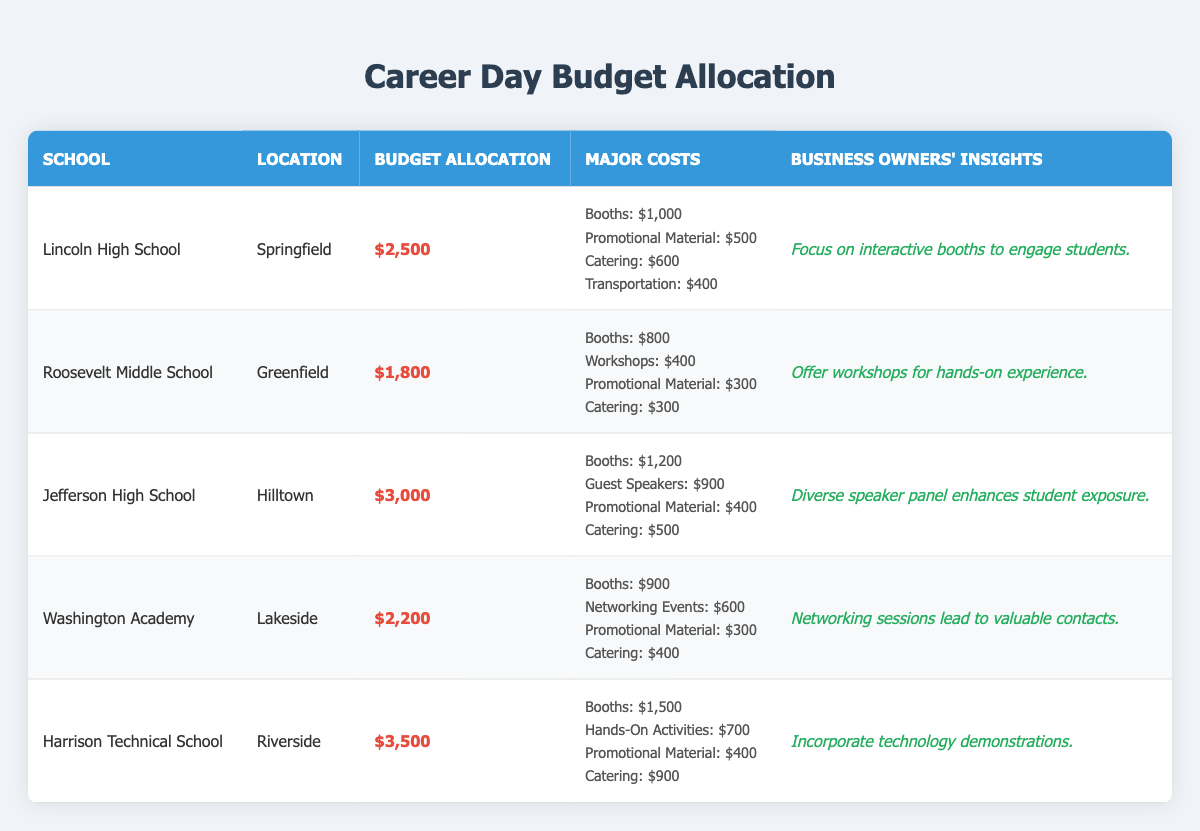What is the highest budget allocation among the schools? The budget allocations listed are $2,500 for Lincoln High School, $1,800 for Roosevelt Middle School, $3,000 for Jefferson High School, $2,200 for Washington Academy, and $3,500 for Harrison Technical School. The highest value is $3,500 for Harrison Technical School.
Answer: $3,500 Which school had the lowest budget allocation? The budget allocations are $2,500, $1,800, $3,000, $2,200, and $3,500. Comparing these values, $1,800 for Roosevelt Middle School is the lowest.
Answer: Roosevelt Middle School How much was allocated for catering at Lincoln High School? The major costs for Lincoln High School include catering expenses listed as $600.
Answer: $600 What is the total budget allocation for all five schools? The allocations are $2,500, $1,800, $3,000, $2,200, and $3,500. Summing these gives $2,500 + $1,800 + $3,000 + $2,200 + $3,500 = $13,000.
Answer: $13,000 How much more was spent on booths at Harrison Technical School compared to Roosevelt Middle School? Harrison Technical School spent $1,500 on booths, while Roosevelt Middle School spent $800. The difference is $1,500 - $800 = $700.
Answer: $700 What percentage of the budget allocation at Washington Academy was spent on promotional materials? Washington Academy's budget is $2,200, and they spent $300 on promotional materials. To find the percentage, divide $300 by $2,200 and multiply by 100: ($300 / $2,200) * 100 ≈ 13.64%.
Answer: 13.64% Which school has a higher budget allocation: Jefferson High School or Lincoln High School? Jefferson High School's budget is $3,000 and Lincoln High School's budget is $2,500. Since $3,000 is greater than $2,500, Jefferson has the higher allocation.
Answer: Jefferson High School What are the combined major costs for booths and catering at Roosevelt Middle School? For Roosevelt Middle School, booth costs are $800 and catering costs are $300. Adding these gives $800 + $300 = $1,100.
Answer: $1,100 Is it true that all schools allocated more than $1,500 for booths? The booth allocations are $1,000 for Lincoln High School, $800 for Roosevelt Middle School, $1,200 for Jefferson High School, $900 for Washington Academy, and $1,500 for Harrison Technical School. Not all are more than $1,500, thus the statement is false.
Answer: False What is the average budget allocation across all schools? The total budget is $13,000, divided by 5 schools gives an average of $13,000 / 5 = $2,600.
Answer: $2,600 How many schools have budget allocations over $2,500? The allocations are $2,500, $1,800, $3,000, $2,200, and $3,500. The schools with allocations over $2,500 are Jefferson High School ($3,000) and Harrison Technical School ($3,500), totaling 2 schools.
Answer: 2 